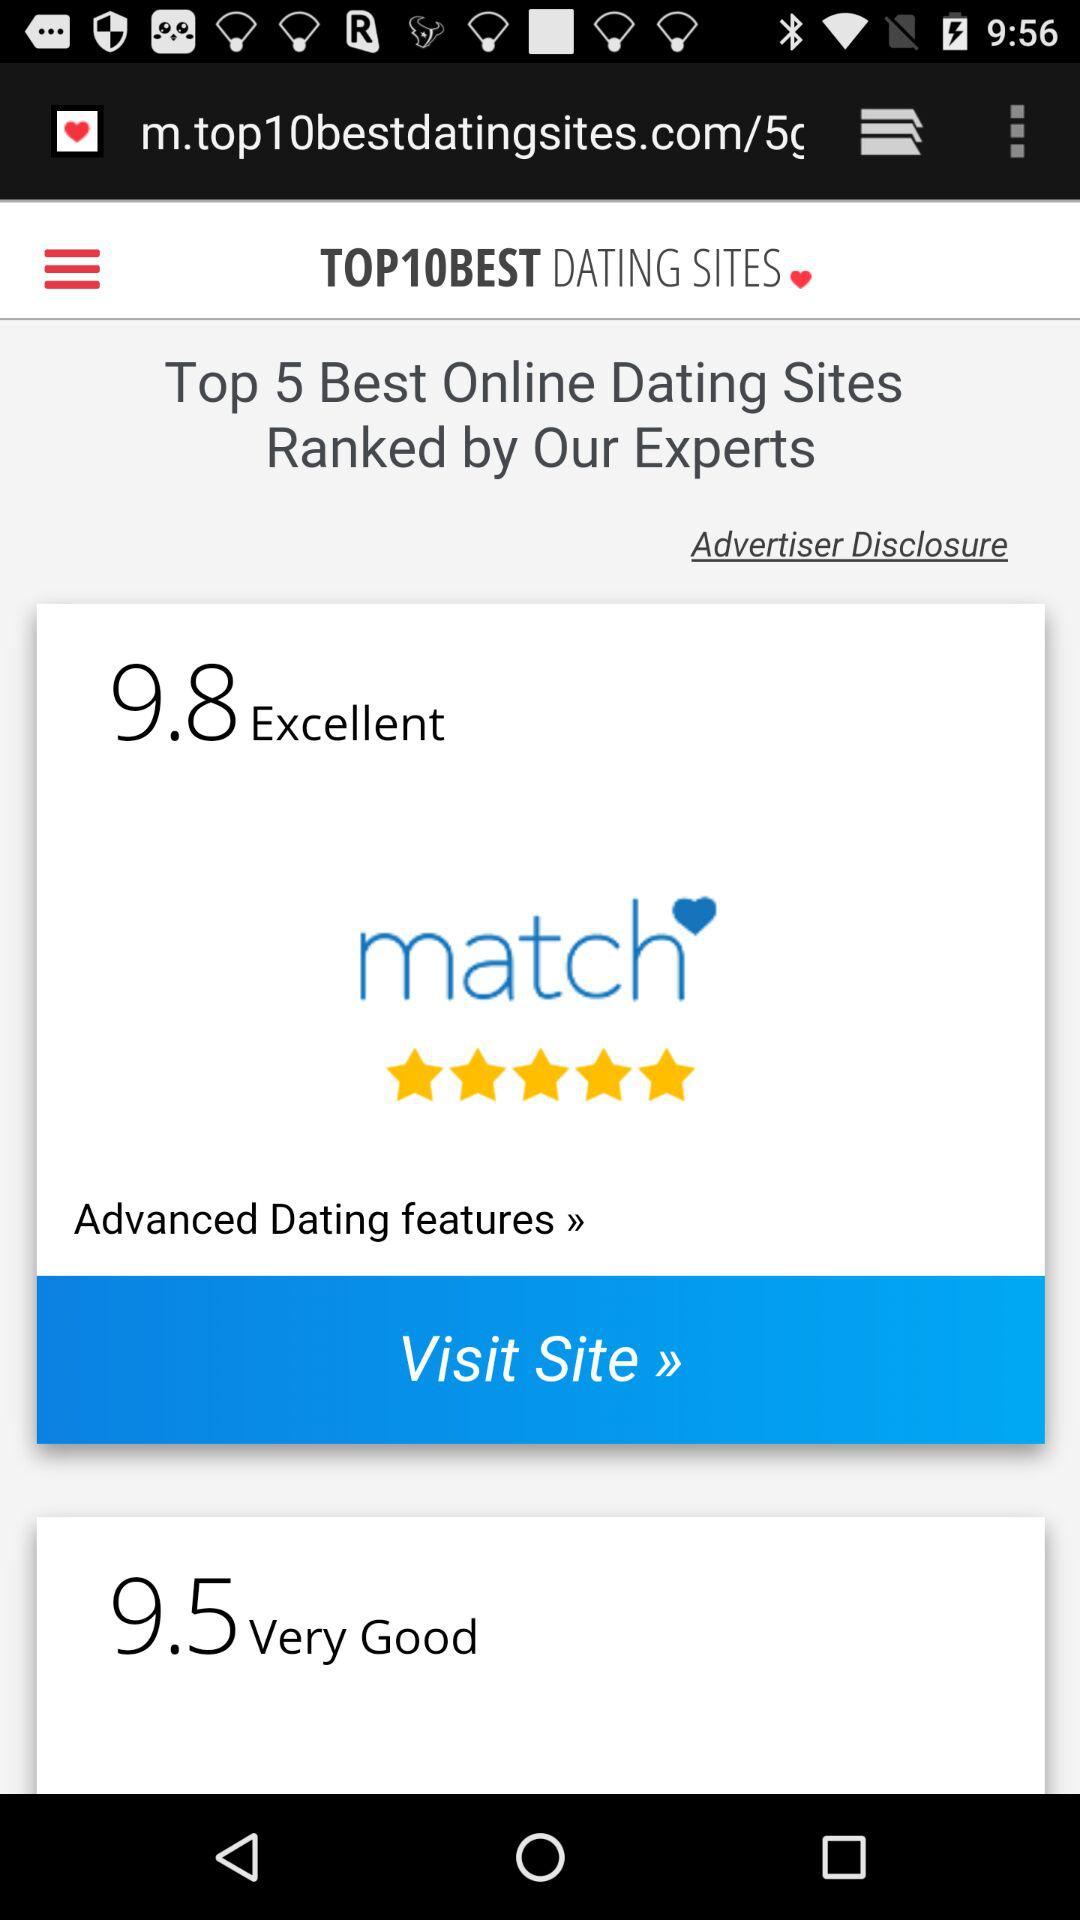What is the rating for "Excellent"? The rating for "Excellent" is 9.8. 